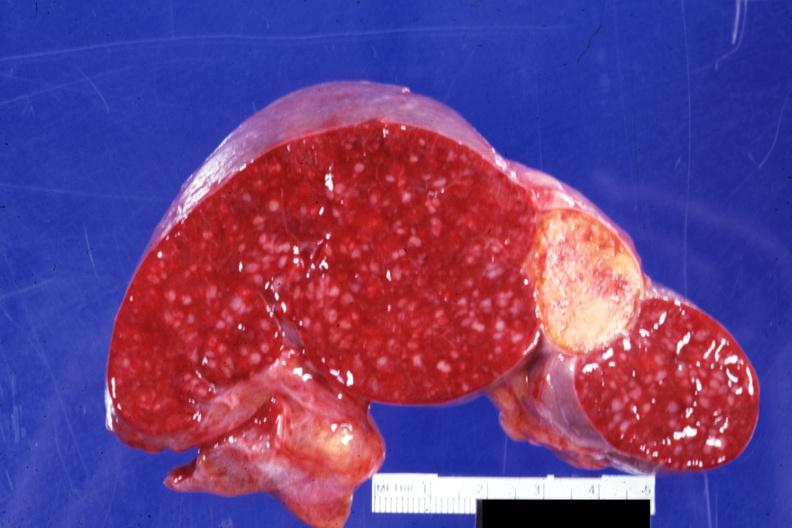how is cut surface with remote and now healed infarct quite typical embolus for valve prosthesis?
Answer the question using a single word or phrase. Aortic 